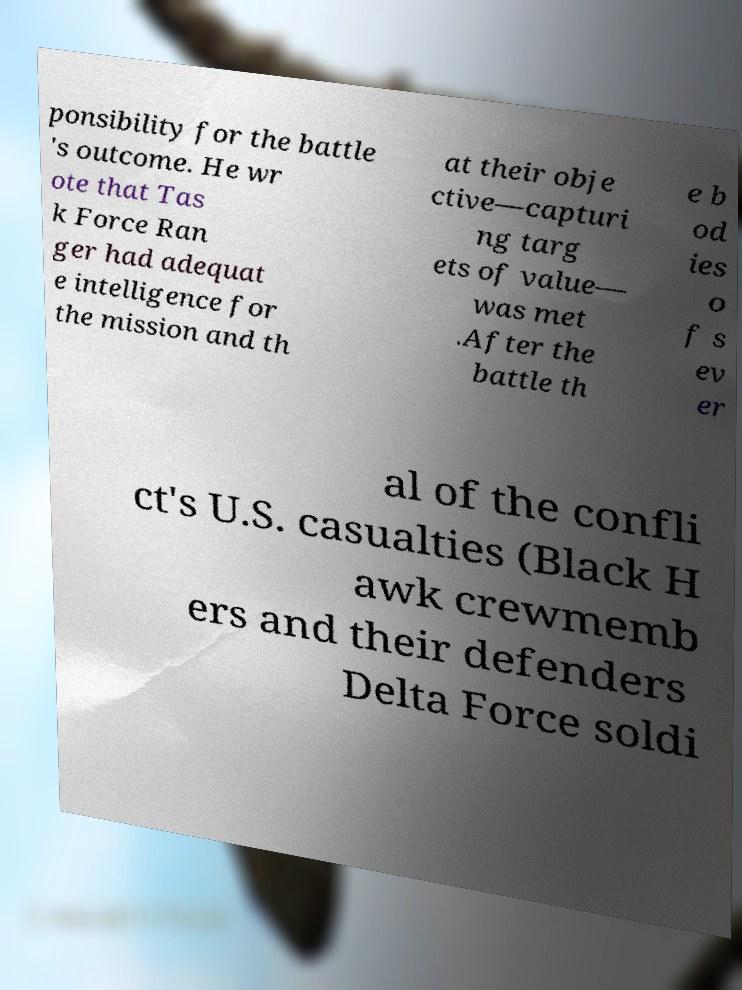There's text embedded in this image that I need extracted. Can you transcribe it verbatim? ponsibility for the battle 's outcome. He wr ote that Tas k Force Ran ger had adequat e intelligence for the mission and th at their obje ctive—capturi ng targ ets of value— was met .After the battle th e b od ies o f s ev er al of the confli ct's U.S. casualties (Black H awk crewmemb ers and their defenders Delta Force soldi 